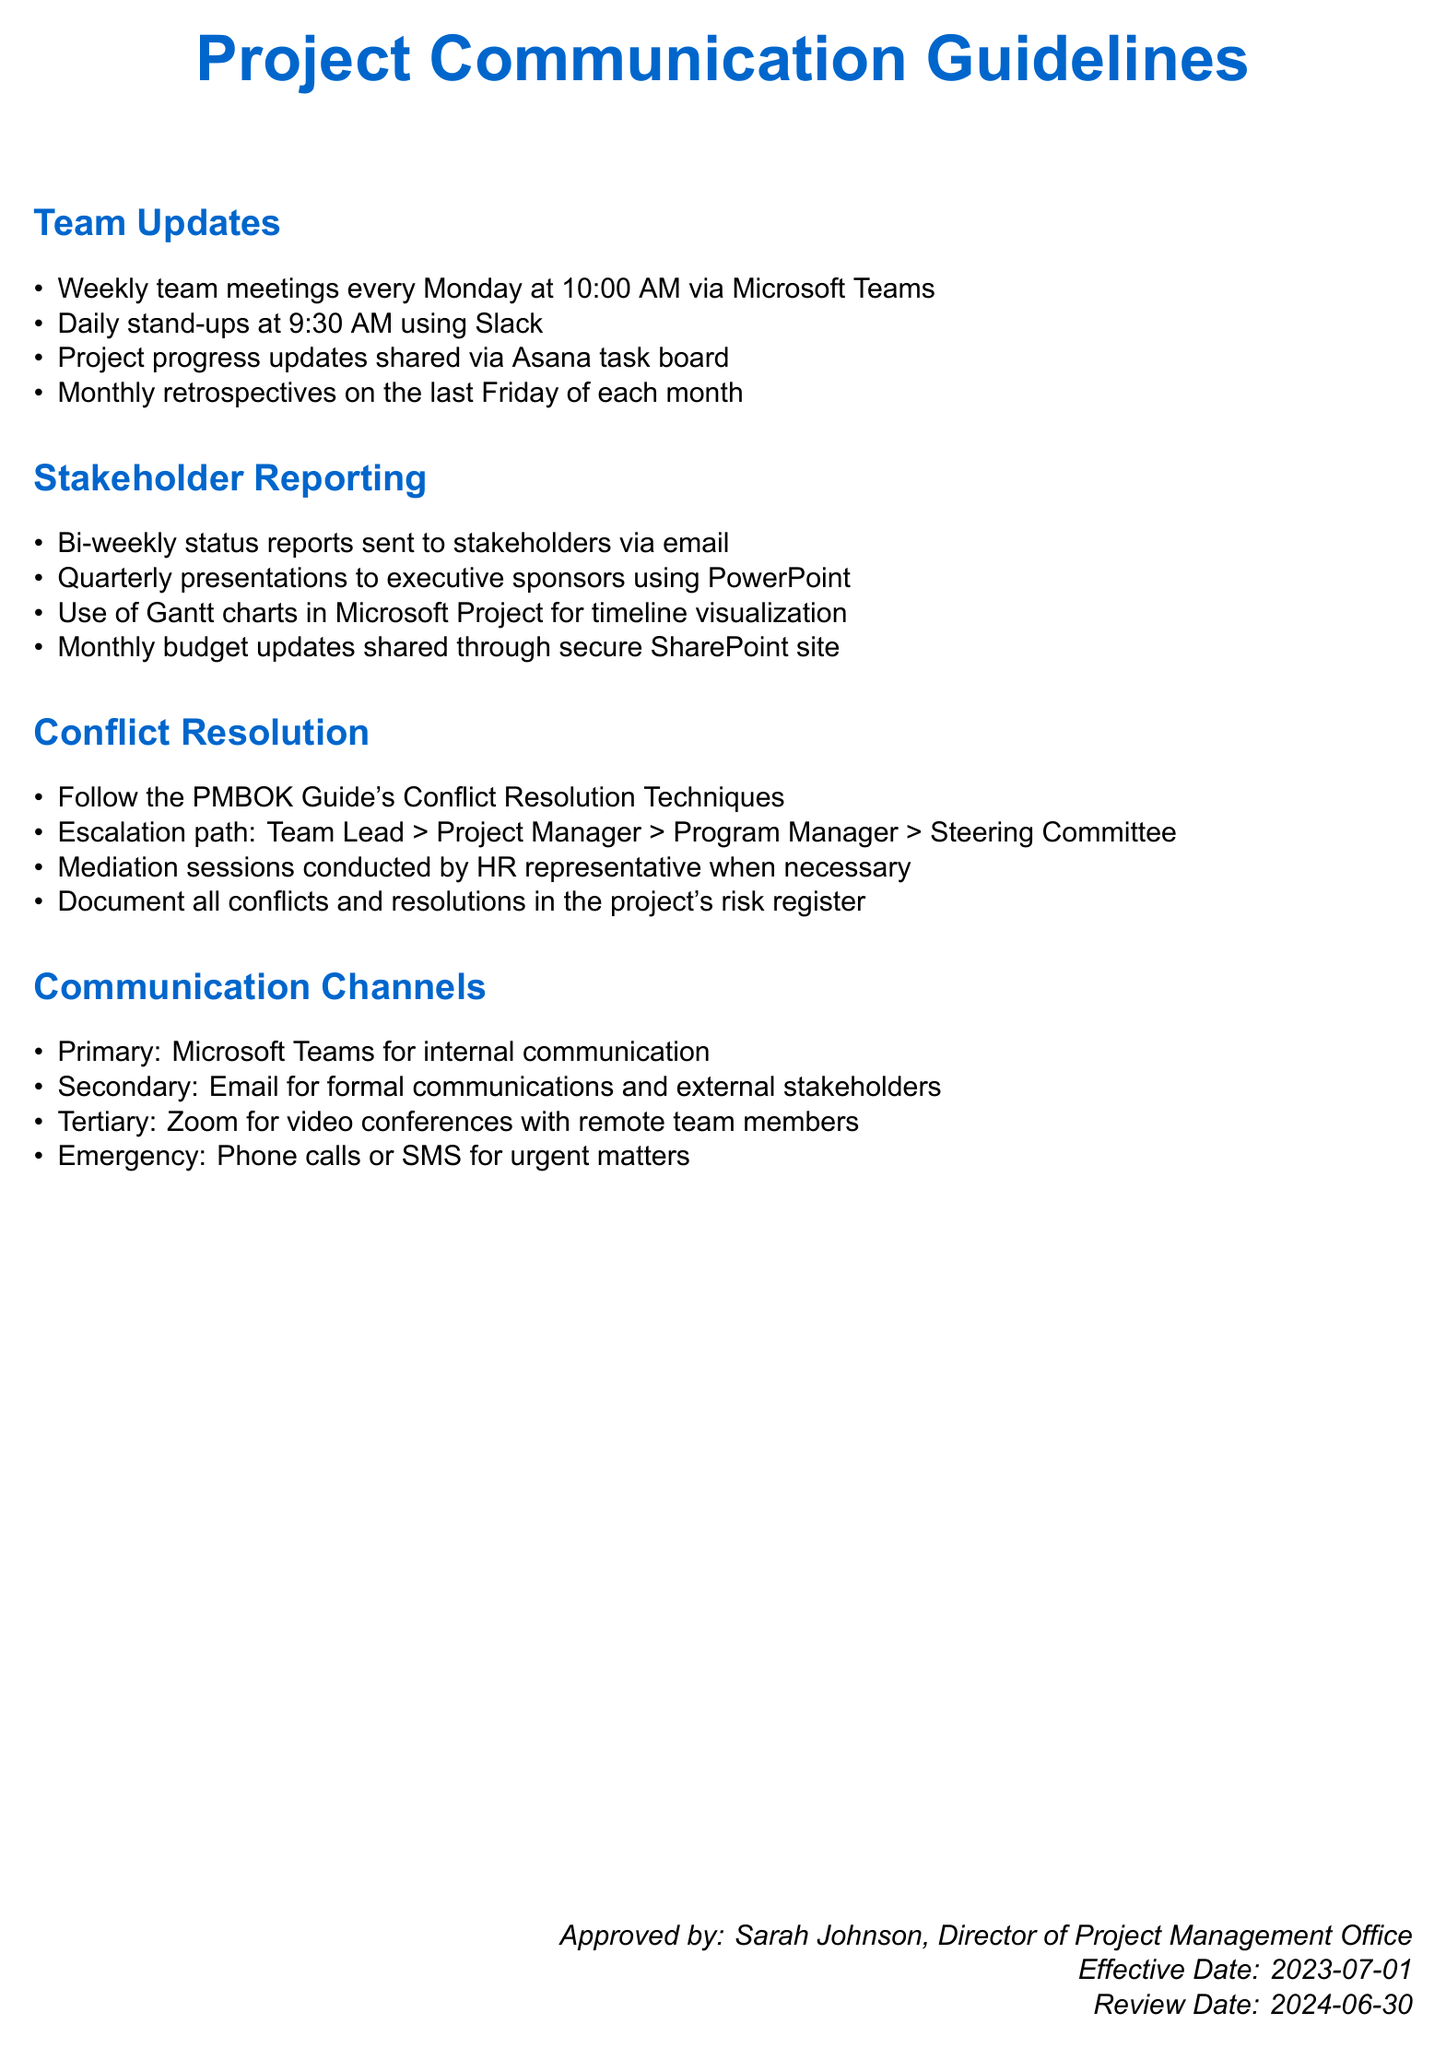What is the time for the weekly team meetings? The document specifies that the weekly team meetings occur every Monday at 10:00 AM.
Answer: 10:00 AM How often are bi-weekly status reports sent? The document indicates that bi-weekly status reports are sent to stakeholders.
Answer: Bi-weekly What is the method for project progress updates? The project progress updates are shared via the Asana task board.
Answer: Asana task board What is the escalation path for conflict resolution? The document outlines the escalation path as Team Lead, Project Manager, Program Manager, Steering Committee.
Answer: Team Lead > Project Manager > Program Manager > Steering Committee Who approves the document? The document states that it was approved by Sarah Johnson, the Director of the Project Management Office.
Answer: Sarah Johnson When are monthly budget updates shared? The document specifies monthly budget updates are shared through a secure SharePoint site.
Answer: Secure SharePoint site What platform is used for daily stand-ups? The document mentions that daily stand-ups are conducted using Slack.
Answer: Slack What is the effective date of the guidelines? The guidelines are effective from the date noted in the document, which is July 1, 2023.
Answer: 2023-07-01 What is the primary communication channel? The document designates Microsoft Teams as the primary channel for internal communication.
Answer: Microsoft Teams 